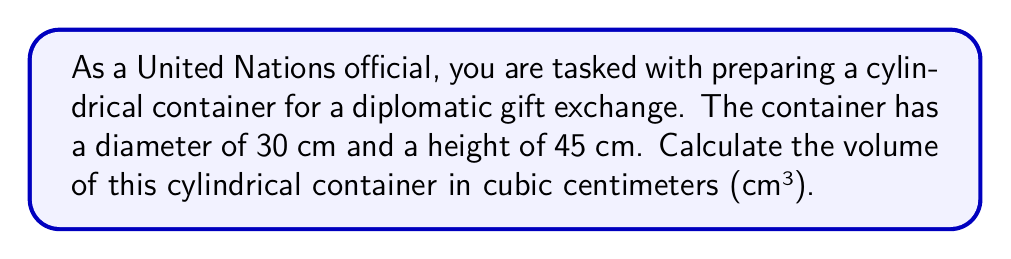Give your solution to this math problem. To solve this problem, we need to use the formula for the volume of a cylinder:

$$V = \pi r^2 h$$

Where:
$V$ = volume of the cylinder
$\pi$ = pi (approximately 3.14159)
$r$ = radius of the base of the cylinder
$h$ = height of the cylinder

Given:
- Diameter = 30 cm
- Height = 45 cm

Step 1: Calculate the radius
The radius is half the diameter:
$r = \frac{30}{2} = 15$ cm

Step 2: Apply the volume formula
$$\begin{align*}
V &= \pi r^2 h \\
&= \pi (15\text{ cm})^2 (45\text{ cm}) \\
&= \pi (225\text{ cm}^2) (45\text{ cm}) \\
&= 31,808.63\text{ cm}^3 \text{ (rounded to 2 decimal places)}
\end{align*}$$

[asy]
import geometry;

size(200);
real r = 3;
real h = 4.5;

path base = circle((0,0), r);
path top = circle((0,h), r);

draw(base);
draw(top);
draw((r,0)--(r,h));
draw((-r,0)--(-r,h));

label("r", (r/2,0), E);
label("h", (r,h/2), E);

draw((0,0)--(r,0), arrow=Arrow(TeXHead));
draw((r,0)--(r,h), arrow=Arrow(TeXHead));
[/asy]
Answer: The volume of the cylindrical diplomatic gift container is approximately 31,808.63 cm³. 